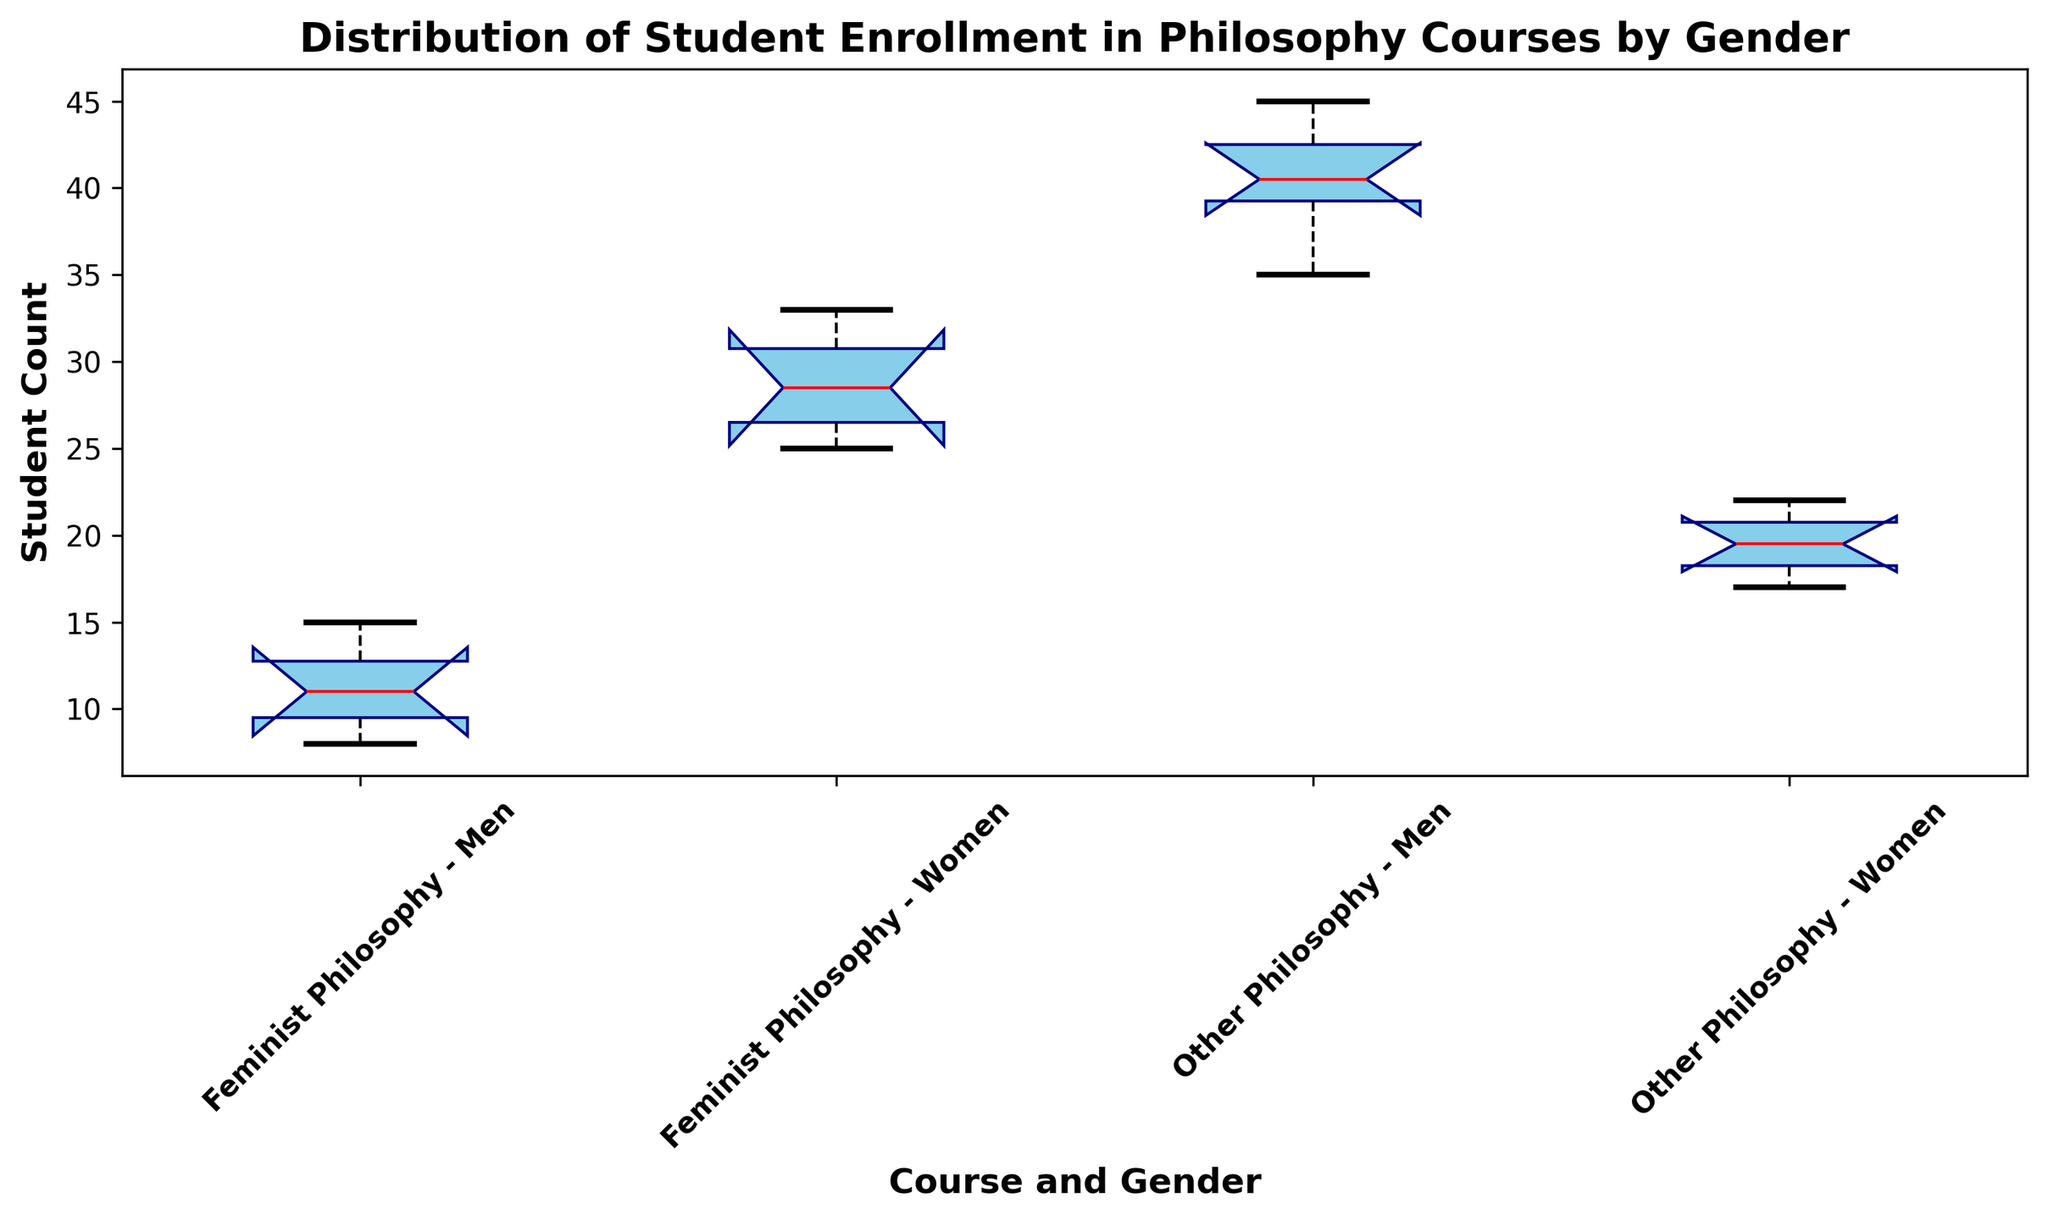What is the median number of students enrolled in Feminist Philosophy courses by men? The box plot shows the median value represented by the red line within the box plot for each group. For Feminist Philosophy - Men, the median value is marked at the appropriate position on the y-axis.
Answer: 12 Which group has the highest median enrollment? Compare the positions of the red median lines for all groups. The group with the highest median line represents the highest median enrollment.
Answer: Feminist Philosophy - Women What is the interquartile range (IQR) of student enrollment for Other Philosophy - Men? The IQR is the difference between the third quartile (Q3) and the first quartile (Q1). From the box plot, identify Q1 and Q3 for Other Philosophy - Men and calculate the difference.
Answer: 6 Does the enrollment of women in Feminist Philosophy courses have more variability than that of men in the same courses? The range of the box (IQR) and the length of the whiskers indicate variability. Compare the IQR and whisker lengths for Feminist Philosophy - Women and Men.
Answer: Yes Which group has the smallest range of student enrollment? The range is the difference between the maximum and minimum values. Look at the length of the whiskers for each group. The group with the shortest whiskers has the smallest range.
Answer: Feminist Philosophy - Men If we combine the median enrollment values for men and women in Feminist Philosophy, what is the total? Sum the median values for Feminist Philosophy - Men and Feminist Philosophy - Women.
Answer: 42 Are there any outliers in the enrollment distribution for Other Philosophy - Women? Outliers are typically represented by individual points outside the whiskers. Check if there are any such points in the box plot for Other Philosophy - Women.
Answer: No Which gender has a higher median enrollment in Other Philosophy courses? Compare the positions of the red median lines for Other Philosophy - Men and Other Philosophy - Women. The higher one indicates the higher median enrollment.
Answer: Men 